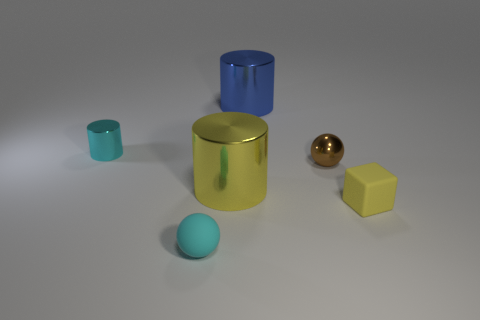Can you tell me the position of the shadows and what that says about the light source? The shadows extend to the left side of the objects, indicating a light source to the right. Analyzing shadows can reveal details about lighting conditions and enhance the sense of depth in an image. 